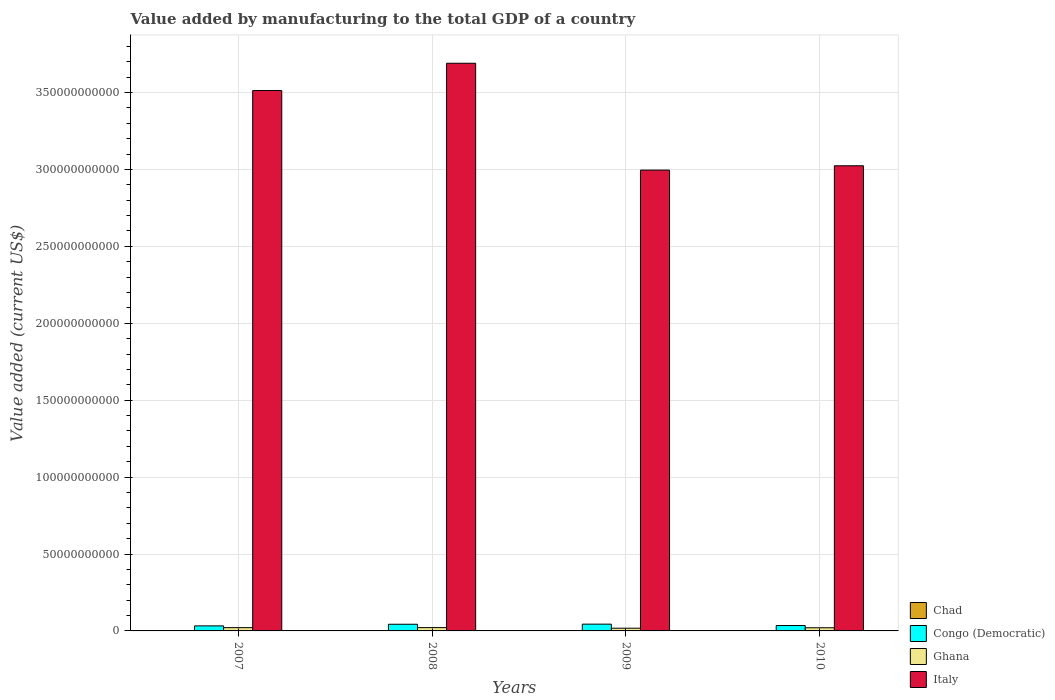How many groups of bars are there?
Offer a very short reply. 4. How many bars are there on the 2nd tick from the left?
Offer a terse response. 4. How many bars are there on the 1st tick from the right?
Provide a short and direct response. 4. What is the label of the 2nd group of bars from the left?
Offer a terse response. 2008. What is the value added by manufacturing to the total GDP in Chad in 2009?
Provide a succinct answer. 9.22e+07. Across all years, what is the maximum value added by manufacturing to the total GDP in Chad?
Provide a succinct answer. 1.04e+08. Across all years, what is the minimum value added by manufacturing to the total GDP in Chad?
Your answer should be very brief. 5.83e+07. In which year was the value added by manufacturing to the total GDP in Congo (Democratic) minimum?
Offer a very short reply. 2007. What is the total value added by manufacturing to the total GDP in Chad in the graph?
Your answer should be very brief. 3.34e+08. What is the difference between the value added by manufacturing to the total GDP in Italy in 2009 and that in 2010?
Your answer should be compact. -2.81e+09. What is the difference between the value added by manufacturing to the total GDP in Chad in 2007 and the value added by manufacturing to the total GDP in Ghana in 2009?
Provide a succinct answer. -1.70e+09. What is the average value added by manufacturing to the total GDP in Ghana per year?
Make the answer very short. 2.02e+09. In the year 2007, what is the difference between the value added by manufacturing to the total GDP in Congo (Democratic) and value added by manufacturing to the total GDP in Chad?
Give a very brief answer. 3.22e+09. What is the ratio of the value added by manufacturing to the total GDP in Congo (Democratic) in 2009 to that in 2010?
Provide a succinct answer. 1.26. Is the difference between the value added by manufacturing to the total GDP in Congo (Democratic) in 2007 and 2010 greater than the difference between the value added by manufacturing to the total GDP in Chad in 2007 and 2010?
Provide a succinct answer. No. What is the difference between the highest and the second highest value added by manufacturing to the total GDP in Congo (Democratic)?
Make the answer very short. 6.72e+07. What is the difference between the highest and the lowest value added by manufacturing to the total GDP in Chad?
Provide a succinct answer. 4.53e+07. Is it the case that in every year, the sum of the value added by manufacturing to the total GDP in Chad and value added by manufacturing to the total GDP in Italy is greater than the sum of value added by manufacturing to the total GDP in Ghana and value added by manufacturing to the total GDP in Congo (Democratic)?
Offer a very short reply. Yes. What does the 2nd bar from the left in 2009 represents?
Offer a very short reply. Congo (Democratic). How many bars are there?
Provide a short and direct response. 16. Are all the bars in the graph horizontal?
Your answer should be compact. No. What is the difference between two consecutive major ticks on the Y-axis?
Ensure brevity in your answer.  5.00e+1. Are the values on the major ticks of Y-axis written in scientific E-notation?
Your answer should be very brief. No. Does the graph contain any zero values?
Your response must be concise. No. How many legend labels are there?
Your response must be concise. 4. What is the title of the graph?
Keep it short and to the point. Value added by manufacturing to the total GDP of a country. Does "Hong Kong" appear as one of the legend labels in the graph?
Your answer should be compact. No. What is the label or title of the Y-axis?
Ensure brevity in your answer.  Value added (current US$). What is the Value added (current US$) in Chad in 2007?
Your answer should be compact. 5.83e+07. What is the Value added (current US$) of Congo (Democratic) in 2007?
Give a very brief answer. 3.28e+09. What is the Value added (current US$) in Ghana in 2007?
Make the answer very short. 2.13e+09. What is the Value added (current US$) of Italy in 2007?
Offer a very short reply. 3.51e+11. What is the Value added (current US$) in Chad in 2008?
Keep it short and to the point. 7.95e+07. What is the Value added (current US$) of Congo (Democratic) in 2008?
Ensure brevity in your answer.  4.34e+09. What is the Value added (current US$) of Ghana in 2008?
Keep it short and to the point. 2.15e+09. What is the Value added (current US$) in Italy in 2008?
Offer a very short reply. 3.69e+11. What is the Value added (current US$) of Chad in 2009?
Offer a terse response. 9.22e+07. What is the Value added (current US$) of Congo (Democratic) in 2009?
Provide a succinct answer. 4.40e+09. What is the Value added (current US$) in Ghana in 2009?
Provide a short and direct response. 1.76e+09. What is the Value added (current US$) in Italy in 2009?
Provide a succinct answer. 3.00e+11. What is the Value added (current US$) in Chad in 2010?
Provide a succinct answer. 1.04e+08. What is the Value added (current US$) in Congo (Democratic) in 2010?
Offer a terse response. 3.50e+09. What is the Value added (current US$) in Ghana in 2010?
Ensure brevity in your answer.  2.06e+09. What is the Value added (current US$) of Italy in 2010?
Make the answer very short. 3.02e+11. Across all years, what is the maximum Value added (current US$) of Chad?
Give a very brief answer. 1.04e+08. Across all years, what is the maximum Value added (current US$) of Congo (Democratic)?
Your response must be concise. 4.40e+09. Across all years, what is the maximum Value added (current US$) in Ghana?
Offer a very short reply. 2.15e+09. Across all years, what is the maximum Value added (current US$) in Italy?
Provide a short and direct response. 3.69e+11. Across all years, what is the minimum Value added (current US$) in Chad?
Provide a succinct answer. 5.83e+07. Across all years, what is the minimum Value added (current US$) in Congo (Democratic)?
Keep it short and to the point. 3.28e+09. Across all years, what is the minimum Value added (current US$) of Ghana?
Make the answer very short. 1.76e+09. Across all years, what is the minimum Value added (current US$) in Italy?
Keep it short and to the point. 3.00e+11. What is the total Value added (current US$) of Chad in the graph?
Your response must be concise. 3.34e+08. What is the total Value added (current US$) in Congo (Democratic) in the graph?
Offer a very short reply. 1.55e+1. What is the total Value added (current US$) of Ghana in the graph?
Your response must be concise. 8.10e+09. What is the total Value added (current US$) in Italy in the graph?
Your answer should be very brief. 1.32e+12. What is the difference between the Value added (current US$) of Chad in 2007 and that in 2008?
Keep it short and to the point. -2.11e+07. What is the difference between the Value added (current US$) in Congo (Democratic) in 2007 and that in 2008?
Provide a succinct answer. -1.06e+09. What is the difference between the Value added (current US$) in Ghana in 2007 and that in 2008?
Your response must be concise. -2.37e+07. What is the difference between the Value added (current US$) of Italy in 2007 and that in 2008?
Provide a succinct answer. -1.77e+1. What is the difference between the Value added (current US$) of Chad in 2007 and that in 2009?
Your response must be concise. -3.39e+07. What is the difference between the Value added (current US$) of Congo (Democratic) in 2007 and that in 2009?
Ensure brevity in your answer.  -1.13e+09. What is the difference between the Value added (current US$) in Ghana in 2007 and that in 2009?
Provide a succinct answer. 3.69e+08. What is the difference between the Value added (current US$) in Italy in 2007 and that in 2009?
Offer a very short reply. 5.17e+1. What is the difference between the Value added (current US$) in Chad in 2007 and that in 2010?
Make the answer very short. -4.53e+07. What is the difference between the Value added (current US$) of Congo (Democratic) in 2007 and that in 2010?
Your response must be concise. -2.21e+08. What is the difference between the Value added (current US$) of Ghana in 2007 and that in 2010?
Give a very brief answer. 7.28e+07. What is the difference between the Value added (current US$) in Italy in 2007 and that in 2010?
Make the answer very short. 4.89e+1. What is the difference between the Value added (current US$) in Chad in 2008 and that in 2009?
Your answer should be compact. -1.27e+07. What is the difference between the Value added (current US$) in Congo (Democratic) in 2008 and that in 2009?
Offer a terse response. -6.72e+07. What is the difference between the Value added (current US$) of Ghana in 2008 and that in 2009?
Your answer should be very brief. 3.93e+08. What is the difference between the Value added (current US$) of Italy in 2008 and that in 2009?
Make the answer very short. 6.95e+1. What is the difference between the Value added (current US$) of Chad in 2008 and that in 2010?
Give a very brief answer. -2.42e+07. What is the difference between the Value added (current US$) in Congo (Democratic) in 2008 and that in 2010?
Your response must be concise. 8.37e+08. What is the difference between the Value added (current US$) of Ghana in 2008 and that in 2010?
Provide a short and direct response. 9.66e+07. What is the difference between the Value added (current US$) in Italy in 2008 and that in 2010?
Your answer should be compact. 6.66e+1. What is the difference between the Value added (current US$) of Chad in 2009 and that in 2010?
Your answer should be very brief. -1.15e+07. What is the difference between the Value added (current US$) of Congo (Democratic) in 2009 and that in 2010?
Provide a short and direct response. 9.05e+08. What is the difference between the Value added (current US$) of Ghana in 2009 and that in 2010?
Give a very brief answer. -2.96e+08. What is the difference between the Value added (current US$) in Italy in 2009 and that in 2010?
Your answer should be compact. -2.81e+09. What is the difference between the Value added (current US$) in Chad in 2007 and the Value added (current US$) in Congo (Democratic) in 2008?
Provide a succinct answer. -4.28e+09. What is the difference between the Value added (current US$) of Chad in 2007 and the Value added (current US$) of Ghana in 2008?
Offer a very short reply. -2.09e+09. What is the difference between the Value added (current US$) of Chad in 2007 and the Value added (current US$) of Italy in 2008?
Your answer should be very brief. -3.69e+11. What is the difference between the Value added (current US$) in Congo (Democratic) in 2007 and the Value added (current US$) in Ghana in 2008?
Your answer should be compact. 1.13e+09. What is the difference between the Value added (current US$) of Congo (Democratic) in 2007 and the Value added (current US$) of Italy in 2008?
Make the answer very short. -3.66e+11. What is the difference between the Value added (current US$) in Ghana in 2007 and the Value added (current US$) in Italy in 2008?
Your answer should be compact. -3.67e+11. What is the difference between the Value added (current US$) of Chad in 2007 and the Value added (current US$) of Congo (Democratic) in 2009?
Offer a terse response. -4.34e+09. What is the difference between the Value added (current US$) in Chad in 2007 and the Value added (current US$) in Ghana in 2009?
Your answer should be very brief. -1.70e+09. What is the difference between the Value added (current US$) of Chad in 2007 and the Value added (current US$) of Italy in 2009?
Ensure brevity in your answer.  -2.99e+11. What is the difference between the Value added (current US$) of Congo (Democratic) in 2007 and the Value added (current US$) of Ghana in 2009?
Make the answer very short. 1.52e+09. What is the difference between the Value added (current US$) in Congo (Democratic) in 2007 and the Value added (current US$) in Italy in 2009?
Offer a terse response. -2.96e+11. What is the difference between the Value added (current US$) in Ghana in 2007 and the Value added (current US$) in Italy in 2009?
Ensure brevity in your answer.  -2.97e+11. What is the difference between the Value added (current US$) of Chad in 2007 and the Value added (current US$) of Congo (Democratic) in 2010?
Offer a terse response. -3.44e+09. What is the difference between the Value added (current US$) in Chad in 2007 and the Value added (current US$) in Ghana in 2010?
Make the answer very short. -2.00e+09. What is the difference between the Value added (current US$) of Chad in 2007 and the Value added (current US$) of Italy in 2010?
Give a very brief answer. -3.02e+11. What is the difference between the Value added (current US$) in Congo (Democratic) in 2007 and the Value added (current US$) in Ghana in 2010?
Ensure brevity in your answer.  1.22e+09. What is the difference between the Value added (current US$) of Congo (Democratic) in 2007 and the Value added (current US$) of Italy in 2010?
Your answer should be compact. -2.99e+11. What is the difference between the Value added (current US$) in Ghana in 2007 and the Value added (current US$) in Italy in 2010?
Provide a short and direct response. -3.00e+11. What is the difference between the Value added (current US$) of Chad in 2008 and the Value added (current US$) of Congo (Democratic) in 2009?
Offer a very short reply. -4.32e+09. What is the difference between the Value added (current US$) in Chad in 2008 and the Value added (current US$) in Ghana in 2009?
Ensure brevity in your answer.  -1.68e+09. What is the difference between the Value added (current US$) in Chad in 2008 and the Value added (current US$) in Italy in 2009?
Give a very brief answer. -2.99e+11. What is the difference between the Value added (current US$) in Congo (Democratic) in 2008 and the Value added (current US$) in Ghana in 2009?
Offer a terse response. 2.58e+09. What is the difference between the Value added (current US$) in Congo (Democratic) in 2008 and the Value added (current US$) in Italy in 2009?
Your response must be concise. -2.95e+11. What is the difference between the Value added (current US$) in Ghana in 2008 and the Value added (current US$) in Italy in 2009?
Keep it short and to the point. -2.97e+11. What is the difference between the Value added (current US$) in Chad in 2008 and the Value added (current US$) in Congo (Democratic) in 2010?
Your response must be concise. -3.42e+09. What is the difference between the Value added (current US$) of Chad in 2008 and the Value added (current US$) of Ghana in 2010?
Your response must be concise. -1.98e+09. What is the difference between the Value added (current US$) of Chad in 2008 and the Value added (current US$) of Italy in 2010?
Your answer should be very brief. -3.02e+11. What is the difference between the Value added (current US$) of Congo (Democratic) in 2008 and the Value added (current US$) of Ghana in 2010?
Offer a terse response. 2.28e+09. What is the difference between the Value added (current US$) in Congo (Democratic) in 2008 and the Value added (current US$) in Italy in 2010?
Your answer should be compact. -2.98e+11. What is the difference between the Value added (current US$) of Ghana in 2008 and the Value added (current US$) of Italy in 2010?
Provide a succinct answer. -3.00e+11. What is the difference between the Value added (current US$) in Chad in 2009 and the Value added (current US$) in Congo (Democratic) in 2010?
Keep it short and to the point. -3.41e+09. What is the difference between the Value added (current US$) of Chad in 2009 and the Value added (current US$) of Ghana in 2010?
Give a very brief answer. -1.96e+09. What is the difference between the Value added (current US$) in Chad in 2009 and the Value added (current US$) in Italy in 2010?
Ensure brevity in your answer.  -3.02e+11. What is the difference between the Value added (current US$) of Congo (Democratic) in 2009 and the Value added (current US$) of Ghana in 2010?
Keep it short and to the point. 2.35e+09. What is the difference between the Value added (current US$) of Congo (Democratic) in 2009 and the Value added (current US$) of Italy in 2010?
Your answer should be compact. -2.98e+11. What is the difference between the Value added (current US$) in Ghana in 2009 and the Value added (current US$) in Italy in 2010?
Provide a short and direct response. -3.01e+11. What is the average Value added (current US$) in Chad per year?
Your answer should be very brief. 8.34e+07. What is the average Value added (current US$) of Congo (Democratic) per year?
Offer a terse response. 3.88e+09. What is the average Value added (current US$) in Ghana per year?
Keep it short and to the point. 2.02e+09. What is the average Value added (current US$) in Italy per year?
Give a very brief answer. 3.31e+11. In the year 2007, what is the difference between the Value added (current US$) of Chad and Value added (current US$) of Congo (Democratic)?
Your answer should be very brief. -3.22e+09. In the year 2007, what is the difference between the Value added (current US$) of Chad and Value added (current US$) of Ghana?
Offer a terse response. -2.07e+09. In the year 2007, what is the difference between the Value added (current US$) of Chad and Value added (current US$) of Italy?
Make the answer very short. -3.51e+11. In the year 2007, what is the difference between the Value added (current US$) of Congo (Democratic) and Value added (current US$) of Ghana?
Provide a short and direct response. 1.15e+09. In the year 2007, what is the difference between the Value added (current US$) of Congo (Democratic) and Value added (current US$) of Italy?
Provide a short and direct response. -3.48e+11. In the year 2007, what is the difference between the Value added (current US$) in Ghana and Value added (current US$) in Italy?
Offer a terse response. -3.49e+11. In the year 2008, what is the difference between the Value added (current US$) of Chad and Value added (current US$) of Congo (Democratic)?
Provide a short and direct response. -4.26e+09. In the year 2008, what is the difference between the Value added (current US$) in Chad and Value added (current US$) in Ghana?
Your response must be concise. -2.07e+09. In the year 2008, what is the difference between the Value added (current US$) of Chad and Value added (current US$) of Italy?
Make the answer very short. -3.69e+11. In the year 2008, what is the difference between the Value added (current US$) in Congo (Democratic) and Value added (current US$) in Ghana?
Keep it short and to the point. 2.18e+09. In the year 2008, what is the difference between the Value added (current US$) of Congo (Democratic) and Value added (current US$) of Italy?
Ensure brevity in your answer.  -3.65e+11. In the year 2008, what is the difference between the Value added (current US$) of Ghana and Value added (current US$) of Italy?
Your answer should be compact. -3.67e+11. In the year 2009, what is the difference between the Value added (current US$) in Chad and Value added (current US$) in Congo (Democratic)?
Offer a terse response. -4.31e+09. In the year 2009, what is the difference between the Value added (current US$) of Chad and Value added (current US$) of Ghana?
Your answer should be compact. -1.67e+09. In the year 2009, what is the difference between the Value added (current US$) of Chad and Value added (current US$) of Italy?
Provide a succinct answer. -2.99e+11. In the year 2009, what is the difference between the Value added (current US$) in Congo (Democratic) and Value added (current US$) in Ghana?
Your answer should be compact. 2.64e+09. In the year 2009, what is the difference between the Value added (current US$) in Congo (Democratic) and Value added (current US$) in Italy?
Provide a succinct answer. -2.95e+11. In the year 2009, what is the difference between the Value added (current US$) in Ghana and Value added (current US$) in Italy?
Provide a short and direct response. -2.98e+11. In the year 2010, what is the difference between the Value added (current US$) of Chad and Value added (current US$) of Congo (Democratic)?
Make the answer very short. -3.39e+09. In the year 2010, what is the difference between the Value added (current US$) of Chad and Value added (current US$) of Ghana?
Your response must be concise. -1.95e+09. In the year 2010, what is the difference between the Value added (current US$) of Chad and Value added (current US$) of Italy?
Give a very brief answer. -3.02e+11. In the year 2010, what is the difference between the Value added (current US$) in Congo (Democratic) and Value added (current US$) in Ghana?
Make the answer very short. 1.44e+09. In the year 2010, what is the difference between the Value added (current US$) in Congo (Democratic) and Value added (current US$) in Italy?
Give a very brief answer. -2.99e+11. In the year 2010, what is the difference between the Value added (current US$) in Ghana and Value added (current US$) in Italy?
Your response must be concise. -3.00e+11. What is the ratio of the Value added (current US$) in Chad in 2007 to that in 2008?
Make the answer very short. 0.73. What is the ratio of the Value added (current US$) in Congo (Democratic) in 2007 to that in 2008?
Your answer should be compact. 0.76. What is the ratio of the Value added (current US$) of Italy in 2007 to that in 2008?
Provide a short and direct response. 0.95. What is the ratio of the Value added (current US$) in Chad in 2007 to that in 2009?
Give a very brief answer. 0.63. What is the ratio of the Value added (current US$) of Congo (Democratic) in 2007 to that in 2009?
Provide a short and direct response. 0.74. What is the ratio of the Value added (current US$) in Ghana in 2007 to that in 2009?
Give a very brief answer. 1.21. What is the ratio of the Value added (current US$) in Italy in 2007 to that in 2009?
Offer a terse response. 1.17. What is the ratio of the Value added (current US$) of Chad in 2007 to that in 2010?
Your response must be concise. 0.56. What is the ratio of the Value added (current US$) in Congo (Democratic) in 2007 to that in 2010?
Offer a very short reply. 0.94. What is the ratio of the Value added (current US$) in Ghana in 2007 to that in 2010?
Offer a terse response. 1.04. What is the ratio of the Value added (current US$) of Italy in 2007 to that in 2010?
Offer a very short reply. 1.16. What is the ratio of the Value added (current US$) in Chad in 2008 to that in 2009?
Provide a succinct answer. 0.86. What is the ratio of the Value added (current US$) of Congo (Democratic) in 2008 to that in 2009?
Make the answer very short. 0.98. What is the ratio of the Value added (current US$) in Ghana in 2008 to that in 2009?
Your answer should be very brief. 1.22. What is the ratio of the Value added (current US$) in Italy in 2008 to that in 2009?
Your answer should be compact. 1.23. What is the ratio of the Value added (current US$) in Chad in 2008 to that in 2010?
Your response must be concise. 0.77. What is the ratio of the Value added (current US$) in Congo (Democratic) in 2008 to that in 2010?
Offer a very short reply. 1.24. What is the ratio of the Value added (current US$) in Ghana in 2008 to that in 2010?
Make the answer very short. 1.05. What is the ratio of the Value added (current US$) in Italy in 2008 to that in 2010?
Give a very brief answer. 1.22. What is the ratio of the Value added (current US$) in Chad in 2009 to that in 2010?
Offer a terse response. 0.89. What is the ratio of the Value added (current US$) of Congo (Democratic) in 2009 to that in 2010?
Your response must be concise. 1.26. What is the ratio of the Value added (current US$) in Ghana in 2009 to that in 2010?
Offer a very short reply. 0.86. What is the difference between the highest and the second highest Value added (current US$) of Chad?
Your answer should be compact. 1.15e+07. What is the difference between the highest and the second highest Value added (current US$) of Congo (Democratic)?
Your answer should be compact. 6.72e+07. What is the difference between the highest and the second highest Value added (current US$) in Ghana?
Provide a succinct answer. 2.37e+07. What is the difference between the highest and the second highest Value added (current US$) in Italy?
Ensure brevity in your answer.  1.77e+1. What is the difference between the highest and the lowest Value added (current US$) in Chad?
Keep it short and to the point. 4.53e+07. What is the difference between the highest and the lowest Value added (current US$) in Congo (Democratic)?
Provide a short and direct response. 1.13e+09. What is the difference between the highest and the lowest Value added (current US$) of Ghana?
Make the answer very short. 3.93e+08. What is the difference between the highest and the lowest Value added (current US$) of Italy?
Provide a short and direct response. 6.95e+1. 